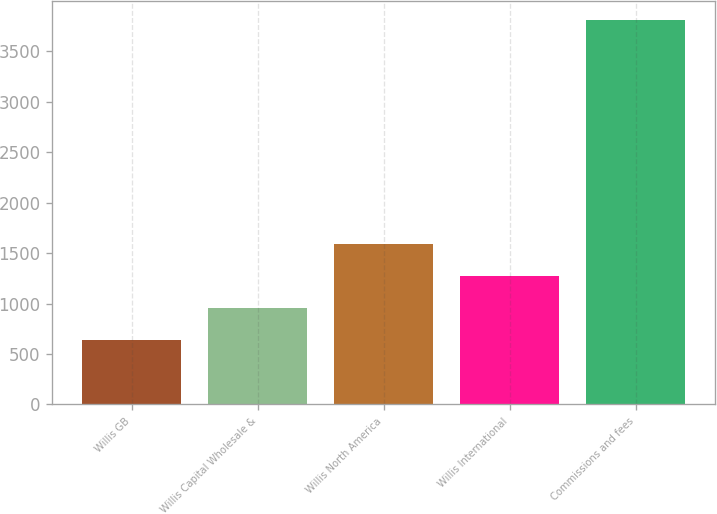<chart> <loc_0><loc_0><loc_500><loc_500><bar_chart><fcel>Willis GB<fcel>Willis Capital Wholesale &<fcel>Willis North America<fcel>Willis International<fcel>Commissions and fees<nl><fcel>637<fcel>954.2<fcel>1588.6<fcel>1271.4<fcel>3809<nl></chart> 